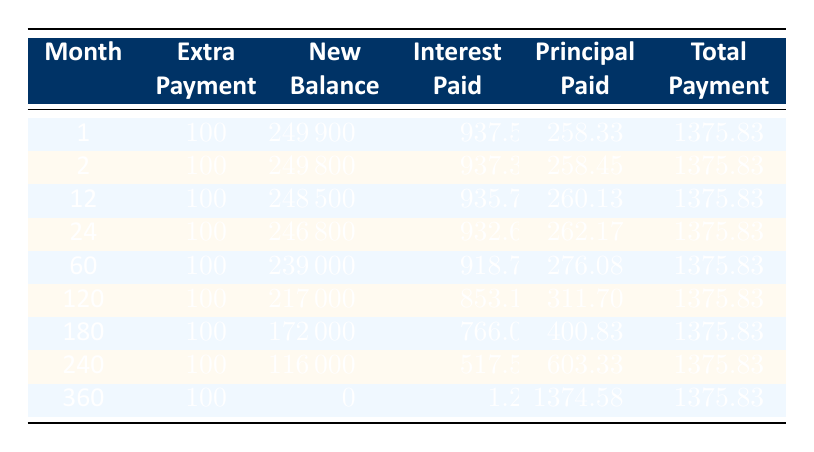What is the new balance after the first extra payment? The new balance after the first month of the extra payment is recorded in the table under the "New Balance" column for month 1, showing a value of 249900.
Answer: 249900 How much interest was paid in month 120? The amount of interest paid in month 120 can be directly found in the "Interest Paid" column for that month, which indicates a value of 853.13.
Answer: 853.13 What is the total interest paid from month 1 to month 24? To find the total interest paid from month 1 to month 24, we need to add the values from the "Interest Paid" column for months 1, 2, 12, and 24: 937.50 + 937.38 + 935.70 + 932.66 = 3743.24.
Answer: 3743.24 Was the principal paid in month 180 more than in month 60? By comparing the "Principal Paid" values for month 180 (400.83) and month 60 (276.08), we can confirm that 400.83 is greater than 276.08, thus the statement is true.
Answer: Yes What is the difference in total payment between month 1 and month 240? Total payment in both months is listed under "Total Payment," which is 1375.83 for both month 1 and month 240. The difference is 1375.83 - 1375.83 = 0.
Answer: 0 How much was the total principal paid in month 360? The total principal paid in month 360 can be found in the "Principal Paid" column for that month, showing a value of 1374.58.
Answer: 1374.58 What is the average principal paid from month 1 to month 12? To calculate the average principal paid between months 1 and 12, we need to sum the principal paid values for months 1 (258.33), 2 (258.45), and 12 (260.13), which amounts to 258.33 + 258.45 + 260.13 = 777.91, then divide by the three months to get an average of 777.91 / 3 = 259.30.
Answer: 259.30 Did the loan balance decrease more significantly from month 180 to month 240 compared to month 24 to month 60? To assess this, we examine the balances: month 180 had a balance of 172000, and month 240 had a balance of 116000, resulting in a drop of 56000. For month 24, the balance was 246800 and went to 239000 in month 60, leading to a decrease of 7800. Since 56000 > 7800, the decrease from month 180 to month 240 is greater.
Answer: Yes 